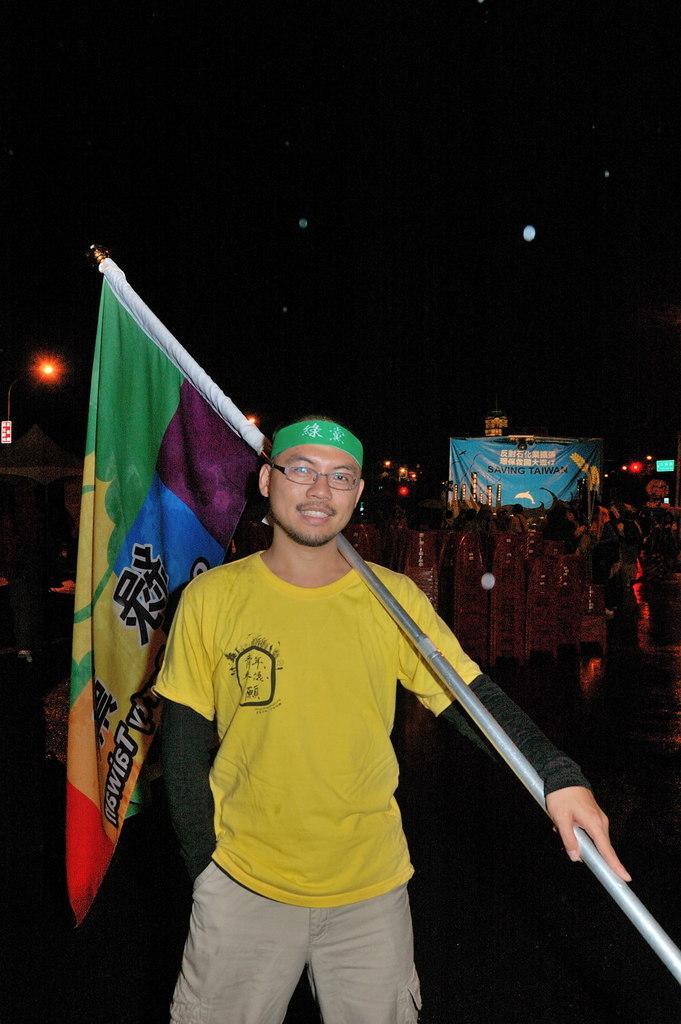Describe this image in one or two sentences. In this image I can see the person with the yellow, black and ash color dress and the person holding the flag. In the background I can see the banner, many objects and the lights. I can see there is a black background. 